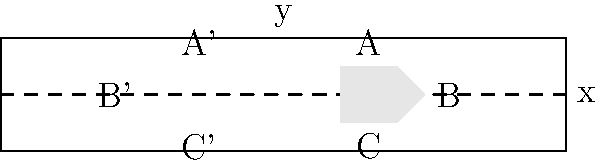A runway marking in the shape of a trapezoid is reflected across the central axis of the runway. If point A on the original marking has coordinates (1.5, 0.5) and point B has coordinates (2.5, 0), what are the coordinates of the corresponding reflected points A' and B'? To solve this problem, we need to understand the concept of reflection across the x-axis:

1. When reflecting a point across the x-axis, the x-coordinate remains the same, but the y-coordinate changes sign.

2. For point A (1.5, 0.5):
   - x-coordinate: 1.5 becomes -1.5 (opposite side of the axis)
   - y-coordinate: 0.5 remains 0.5
   So, A' = (-1.5, 0.5)

3. For point B (2.5, 0):
   - x-coordinate: 2.5 becomes -2.5 (opposite side of the axis)
   - y-coordinate: 0 remains 0
   So, B' = (-2.5, 0)

4. We can verify this visually in the diagram, where A' and B' are indeed in these positions relative to the original points A and B.

This reflection ensures that the runway marking appears symmetrical on both sides of the central axis, which is crucial for proper visual guidance during takeoff and landing procedures.
Answer: A' = (-1.5, 0.5), B' = (-2.5, 0) 